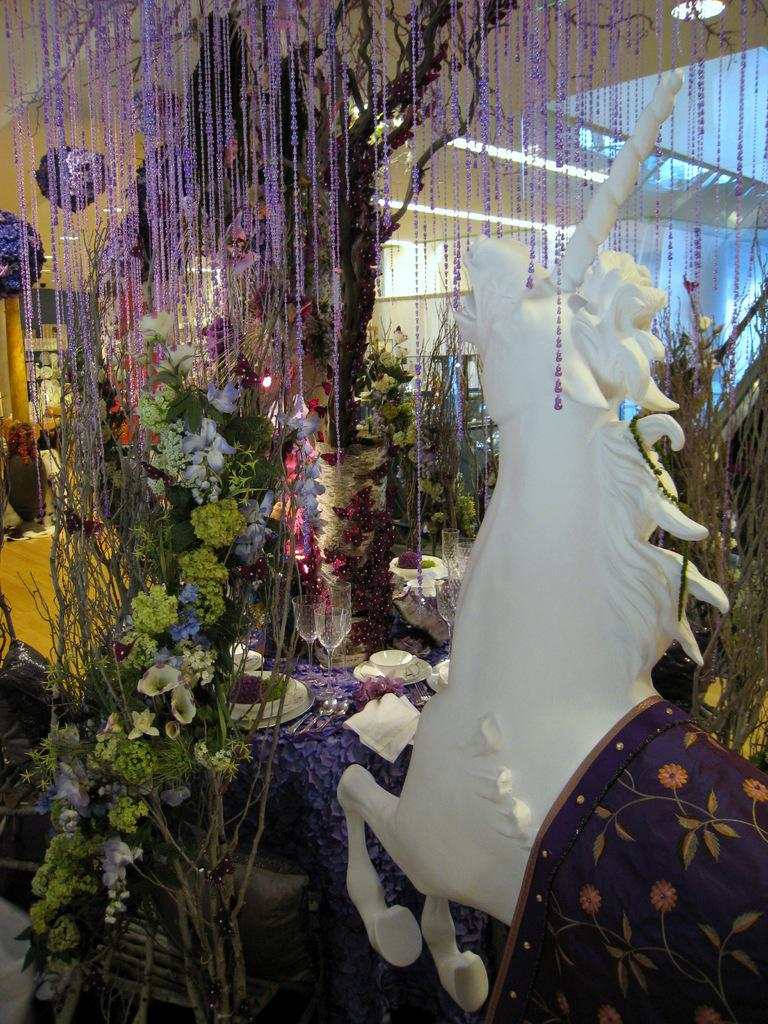What is the main subject on the right side of the image? There is a white color unicorn statue on the right side of the image. What can be seen in the background of the image? There is a decorated tree with some flowers in the background of the image. What type of chin can be seen on the unicorn statue in the image? There is no chin present on the unicorn statue in the image, as it is a statue and not a living creature. 